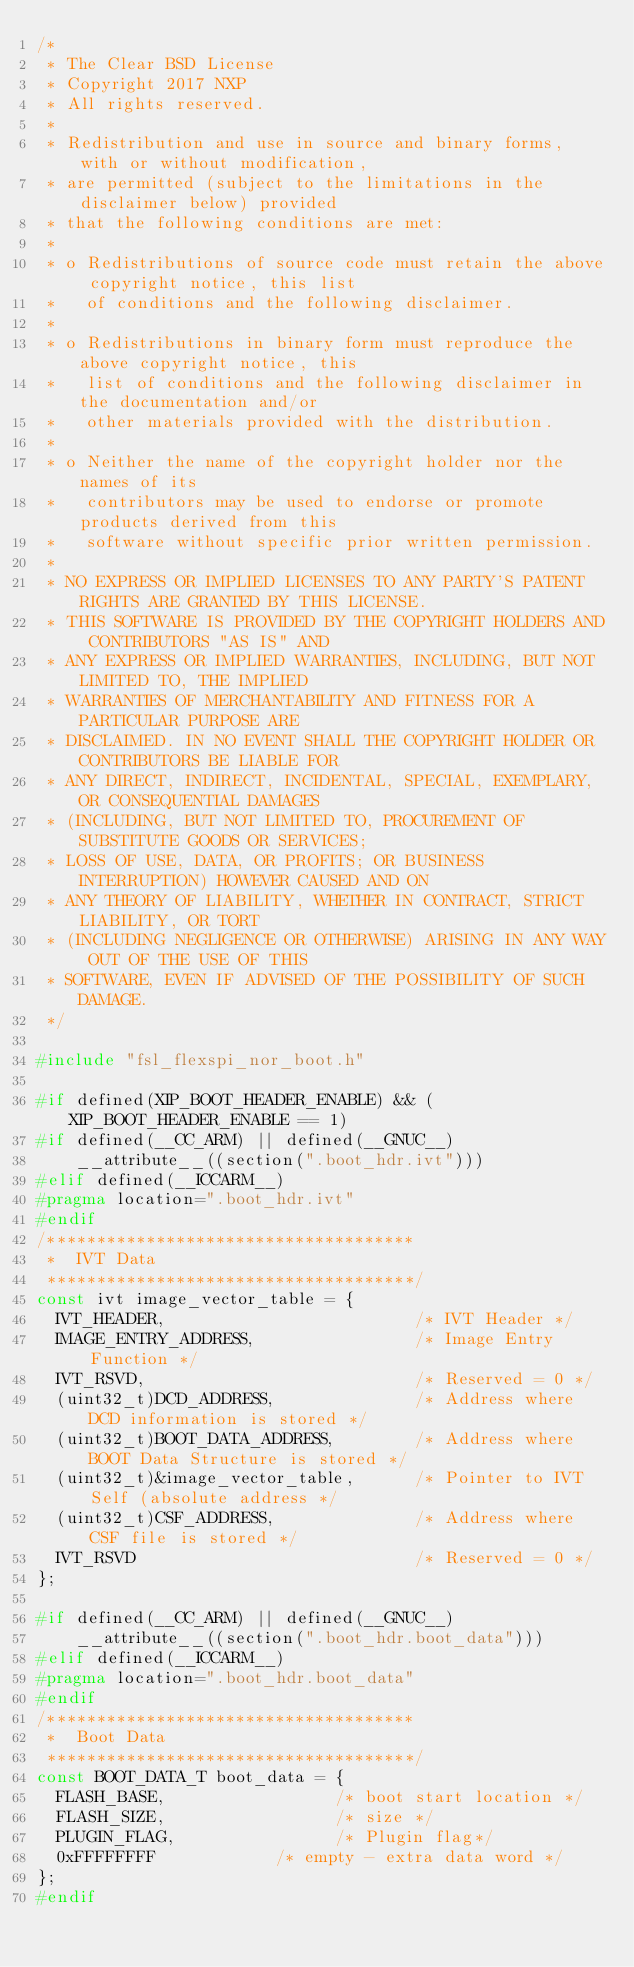Convert code to text. <code><loc_0><loc_0><loc_500><loc_500><_C_>/*
 * The Clear BSD License
 * Copyright 2017 NXP
 * All rights reserved.
 *
 * Redistribution and use in source and binary forms, with or without modification,
 * are permitted (subject to the limitations in the disclaimer below) provided
 * that the following conditions are met:
 *
 * o Redistributions of source code must retain the above copyright notice, this list
 *   of conditions and the following disclaimer.
 *
 * o Redistributions in binary form must reproduce the above copyright notice, this
 *   list of conditions and the following disclaimer in the documentation and/or
 *   other materials provided with the distribution.
 *
 * o Neither the name of the copyright holder nor the names of its
 *   contributors may be used to endorse or promote products derived from this
 *   software without specific prior written permission.
 *
 * NO EXPRESS OR IMPLIED LICENSES TO ANY PARTY'S PATENT RIGHTS ARE GRANTED BY THIS LICENSE.
 * THIS SOFTWARE IS PROVIDED BY THE COPYRIGHT HOLDERS AND CONTRIBUTORS "AS IS" AND
 * ANY EXPRESS OR IMPLIED WARRANTIES, INCLUDING, BUT NOT LIMITED TO, THE IMPLIED
 * WARRANTIES OF MERCHANTABILITY AND FITNESS FOR A PARTICULAR PURPOSE ARE
 * DISCLAIMED. IN NO EVENT SHALL THE COPYRIGHT HOLDER OR CONTRIBUTORS BE LIABLE FOR
 * ANY DIRECT, INDIRECT, INCIDENTAL, SPECIAL, EXEMPLARY, OR CONSEQUENTIAL DAMAGES
 * (INCLUDING, BUT NOT LIMITED TO, PROCUREMENT OF SUBSTITUTE GOODS OR SERVICES;
 * LOSS OF USE, DATA, OR PROFITS; OR BUSINESS INTERRUPTION) HOWEVER CAUSED AND ON
 * ANY THEORY OF LIABILITY, WHETHER IN CONTRACT, STRICT LIABILITY, OR TORT
 * (INCLUDING NEGLIGENCE OR OTHERWISE) ARISING IN ANY WAY OUT OF THE USE OF THIS
 * SOFTWARE, EVEN IF ADVISED OF THE POSSIBILITY OF SUCH DAMAGE.
 */

#include "fsl_flexspi_nor_boot.h"

#if defined(XIP_BOOT_HEADER_ENABLE) && (XIP_BOOT_HEADER_ENABLE == 1)
#if defined(__CC_ARM) || defined(__GNUC__)
    __attribute__((section(".boot_hdr.ivt")))
#elif defined(__ICCARM__)
#pragma location=".boot_hdr.ivt"
#endif
/************************************* 
 *  IVT Data 
 *************************************/
const ivt image_vector_table = {
  IVT_HEADER,                         /* IVT Header */
  IMAGE_ENTRY_ADDRESS,                /* Image Entry Function */
  IVT_RSVD,                           /* Reserved = 0 */
  (uint32_t)DCD_ADDRESS,              /* Address where DCD information is stored */
  (uint32_t)BOOT_DATA_ADDRESS,        /* Address where BOOT Data Structure is stored */
  (uint32_t)&image_vector_table,      /* Pointer to IVT Self (absolute address */
  (uint32_t)CSF_ADDRESS,              /* Address where CSF file is stored */
  IVT_RSVD                            /* Reserved = 0 */
};

#if defined(__CC_ARM) || defined(__GNUC__)
    __attribute__((section(".boot_hdr.boot_data")))
#elif defined(__ICCARM__)
#pragma location=".boot_hdr.boot_data"
#endif
/************************************* 
 *  Boot Data 
 *************************************/
const BOOT_DATA_T boot_data = {
  FLASH_BASE,                 /* boot start location */
  FLASH_SIZE,                 /* size */
  PLUGIN_FLAG,                /* Plugin flag*/
  0xFFFFFFFF  				  /* empty - extra data word */
};
#endif


</code> 